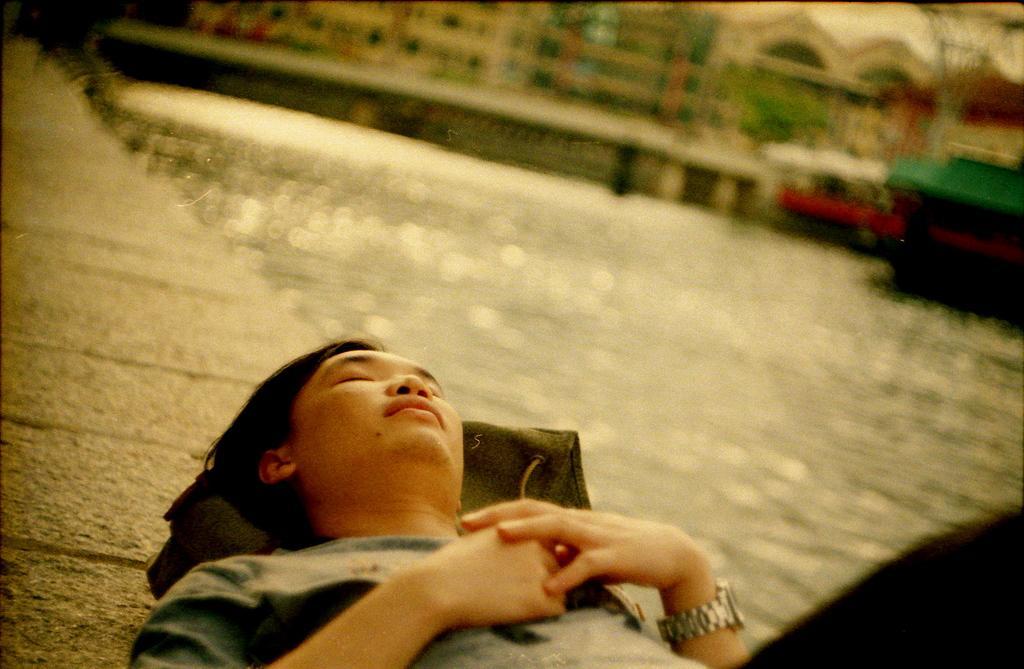Can you describe this image briefly? At the bottom of the image there is a person lying on the wall. In the background of the image there are buildings. There is water. 